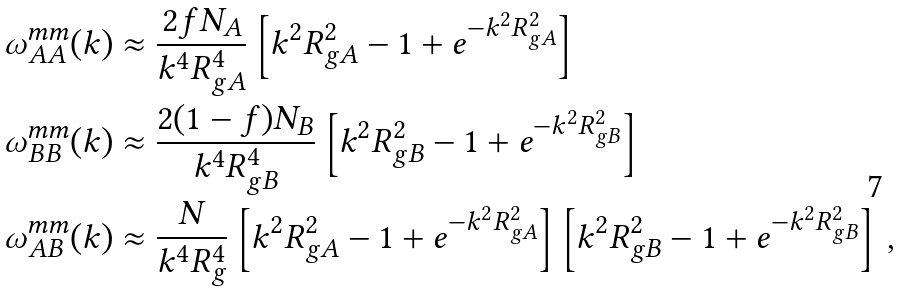<formula> <loc_0><loc_0><loc_500><loc_500>\omega ^ { m m } _ { A A } ( k ) & \approx \frac { 2 f N _ { A } } { k ^ { 4 } R _ { g A } ^ { 4 } } \left [ k ^ { 2 } R _ { g A } ^ { 2 } - 1 + e ^ { - k ^ { 2 } R _ { g A } ^ { 2 } } \right ] \\ \omega ^ { m m } _ { B B } ( k ) & \approx \frac { 2 ( 1 - f ) N _ { B } } { k ^ { 4 } R _ { g B } ^ { 4 } } \left [ k ^ { 2 } R _ { g B } ^ { 2 } - 1 + e ^ { - k ^ { 2 } R _ { g B } ^ { 2 } } \right ] \\ \omega ^ { m m } _ { A B } ( k ) & \approx \frac { N } { k ^ { 4 } R _ { g } ^ { 4 } } \left [ k ^ { 2 } R _ { g A } ^ { 2 } - 1 + e ^ { - k ^ { 2 } R _ { g A } ^ { 2 } } \right ] \left [ k ^ { 2 } R _ { g B } ^ { 2 } - 1 + e ^ { - k ^ { 2 } R _ { g B } ^ { 2 } } \right ] \, ,</formula> 